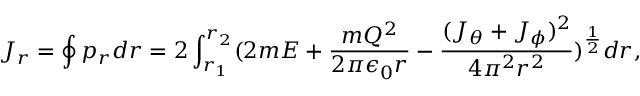Convert formula to latex. <formula><loc_0><loc_0><loc_500><loc_500>J _ { r } = \oint p _ { r } d r = 2 \int _ { r _ { 1 } } ^ { r _ { 2 } } ( 2 m E + { \frac { m Q ^ { 2 } } { 2 \pi \epsilon _ { 0 } r } } - { \frac { ( J _ { \theta } + J _ { \phi } ) ^ { 2 } } { 4 \pi ^ { 2 } r ^ { 2 } } } ) ^ { \frac { 1 } { 2 } } d r ,</formula> 